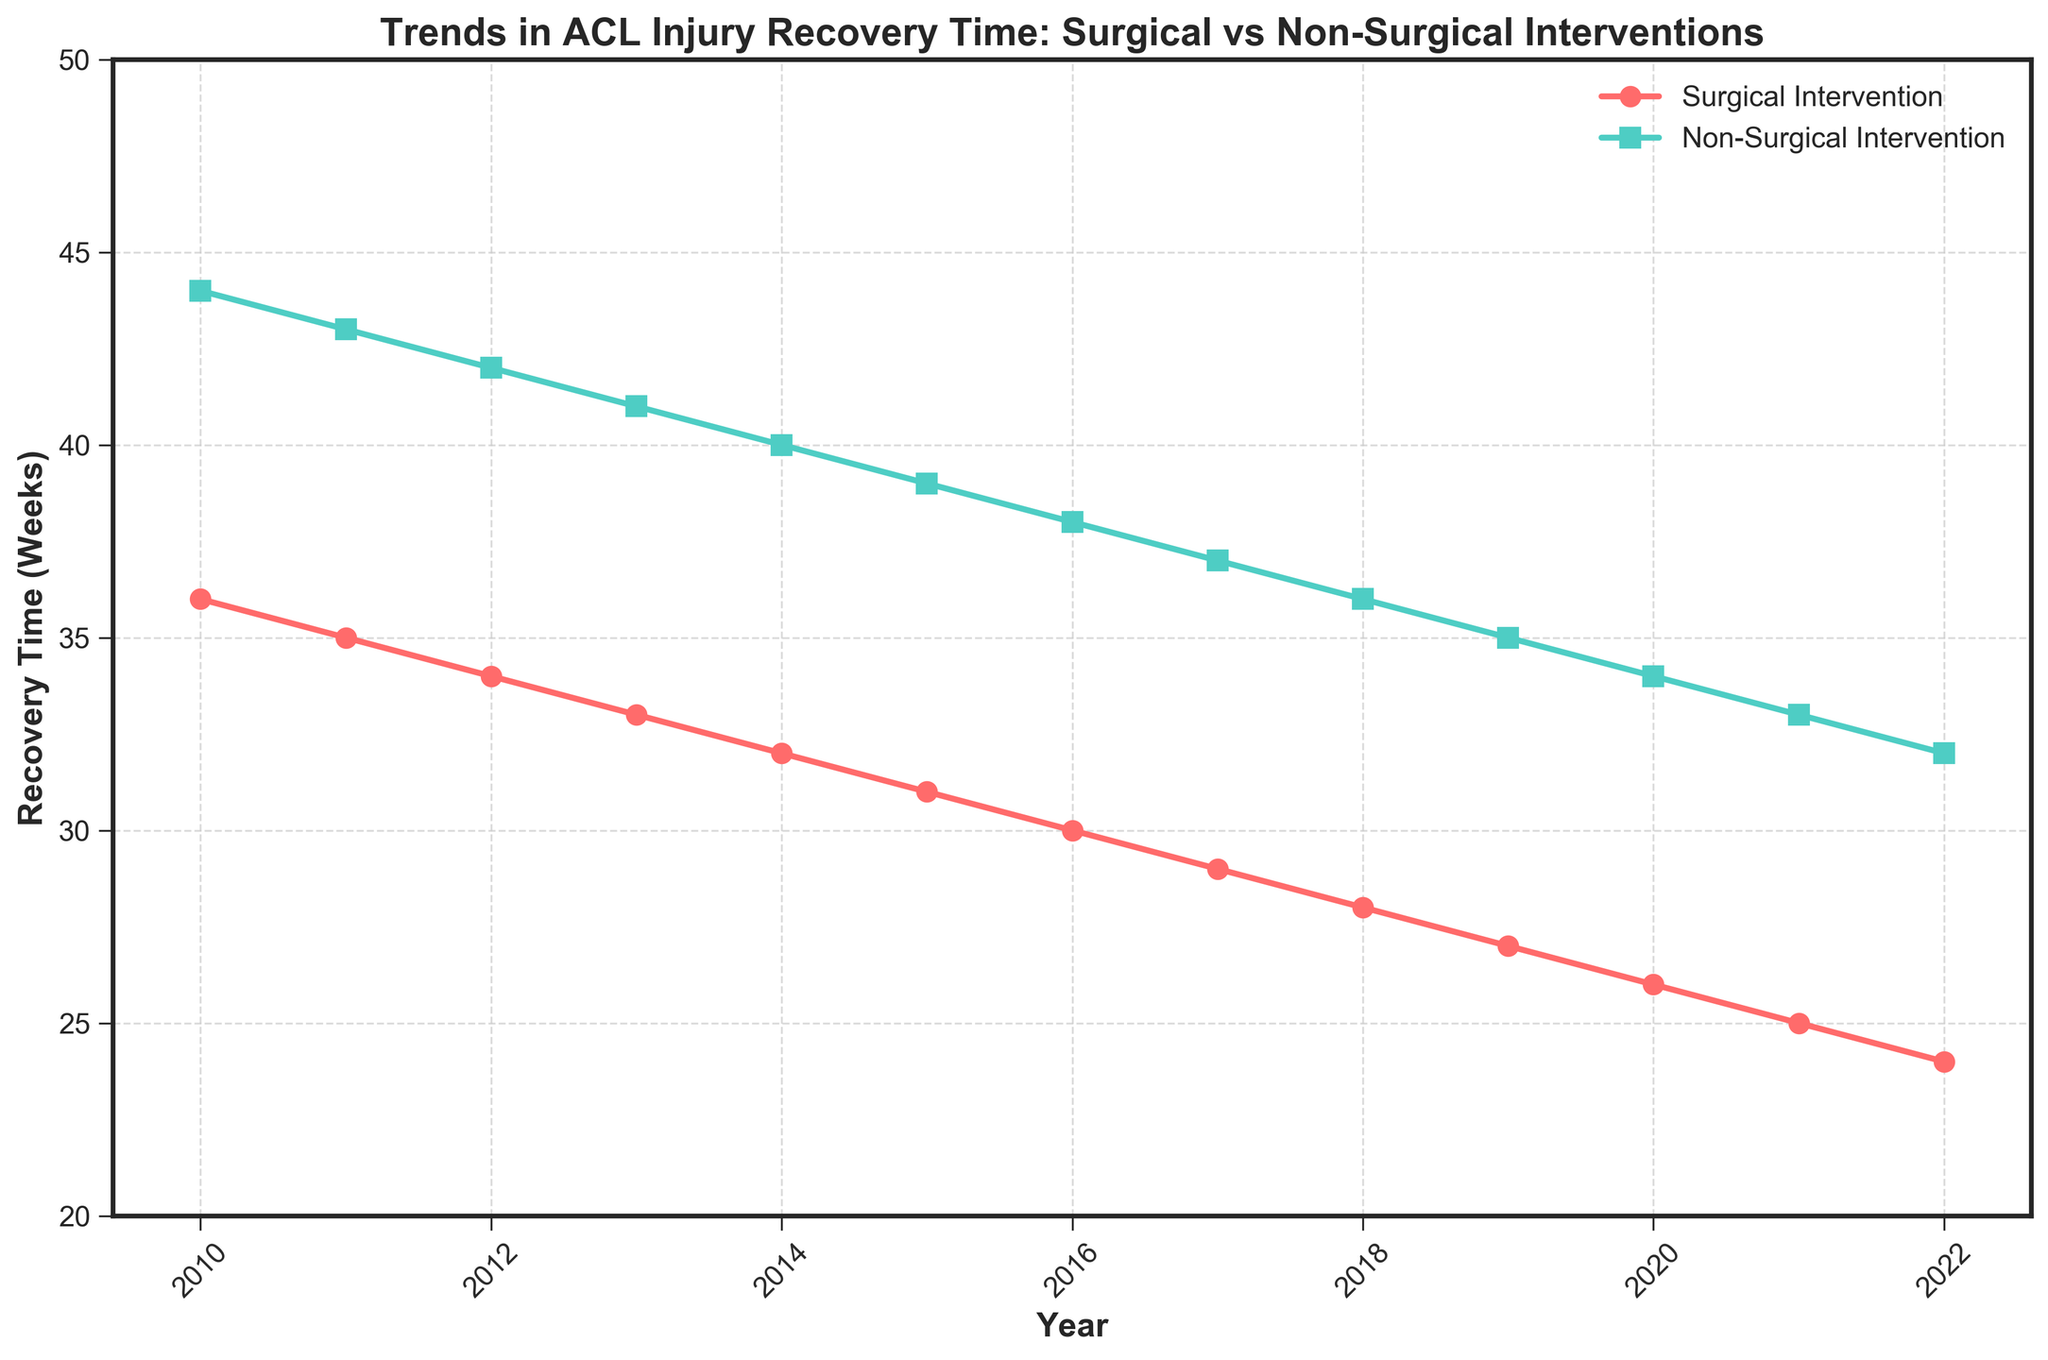What's the overall trend in recovery time for surgical intervention from 2010 to 2022? The trend shows a consistent decrease in recovery time for surgical interventions from 36 weeks in 2010 to 24 weeks in 2022.
Answer: Decreasing Which year shows the smallest difference in recovery time between surgical and non-surgical interventions? In 2022, the difference is smallest, with surgical intervention at 24 weeks and non-surgical intervention at 32 weeks, resulting in an 8-week difference.
Answer: 2022 What is the percentage decrease in recovery time for non-surgical interventions from 2010 to 2022? The decrease is calculated as ((44 - 32) / 44) * 100%. Simplifying this, it becomes (12 / 44) * 100% ≈ 27.27%.
Answer: 27.27% In which year did surgical interventions first result in an average recovery time of less than 30 weeks? By observing the chart, recovery time fell below 30 weeks for surgical intervention in 2017, reaching 29 weeks.
Answer: 2017 Calculate the average recovery time for non-surgical interventions over the entire period. Average = (44 + 43 + 42 + 41 + 40 + 39 + 38 + 37 + 36 + 35 + 34 + 33 + 32) / 13 = 38.
Answer: 38 weeks Which intervention method shows a steeper decline in recovery time over the period 2010 to 2022? By comparing the slopes visually, the surgical intervention curve declines more steeply than the non-surgical intervention curve.
Answer: Surgical intervention How much faster is the recovery time with surgical intervention compared to non-surgical intervention in 2015? In 2015, surgical intervention takes 31 weeks, and non-surgical intervention takes 39 weeks. The time difference is 39 - 31 = 8 weeks.
Answer: 8 weeks Compare the recovery times in 2010 and 2022 for both interventions. Which has seen a greater improvement? For surgical intervention, the improvement is 36 - 24 = 12 weeks. For non-surgical intervention, it is 44 - 32 = 12 weeks. Both have seen the same improvement of 12 weeks.
Answer: Same improvement Identify the year(s) where the recovery time for surgical intervention equals the recovery time for non-surgical intervention minus 8 weeks. By checking each year's data, this condition is met in 2022, where surgical intervention is 24 weeks, and non-surgical intervention is 32 weeks (32 - 8 = 24).
Answer: 2022 